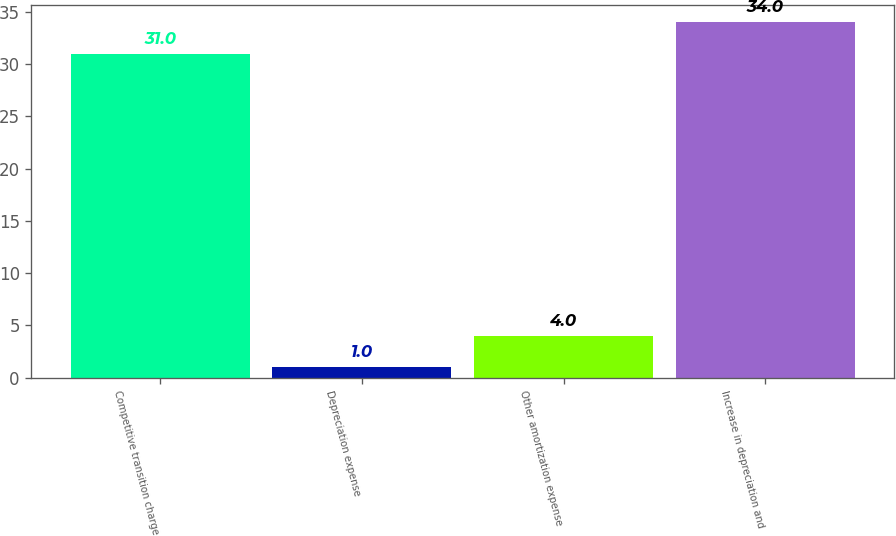Convert chart to OTSL. <chart><loc_0><loc_0><loc_500><loc_500><bar_chart><fcel>Competitive transition charge<fcel>Depreciation expense<fcel>Other amortization expense<fcel>Increase in depreciation and<nl><fcel>31<fcel>1<fcel>4<fcel>34<nl></chart> 